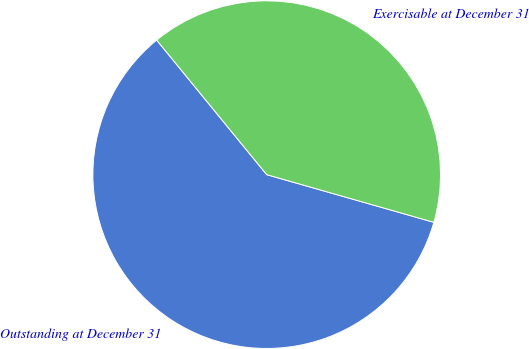Convert chart to OTSL. <chart><loc_0><loc_0><loc_500><loc_500><pie_chart><fcel>Outstanding at December 31<fcel>Exercisable at December 31<nl><fcel>59.67%<fcel>40.33%<nl></chart> 